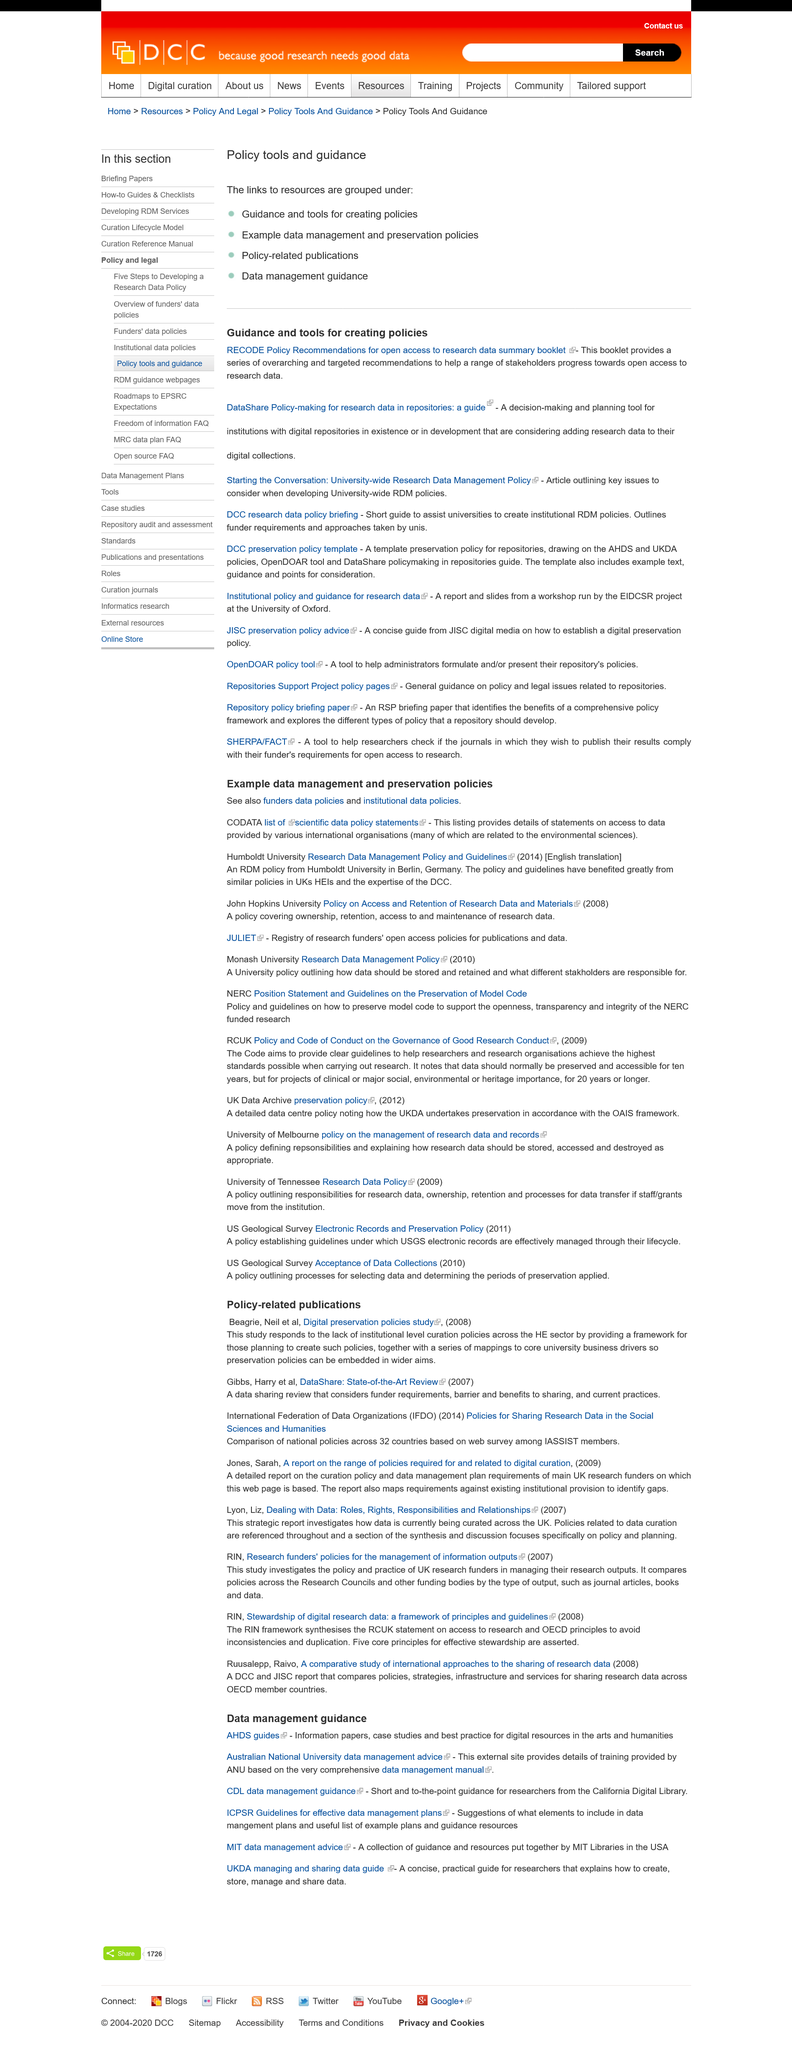Draw attention to some important aspects in this diagram. The 'DataShare Policy-making for research data in repositories: a guide' is a decision-making and planning tool designed specifically for institutions with digital repositories. The RECODE Policy Recommendations booklet and the guide to DataShare Policy-making both involve research data. The RECODE Policy Recommendations booklet provides a series of both overarching and specific recommendations. 